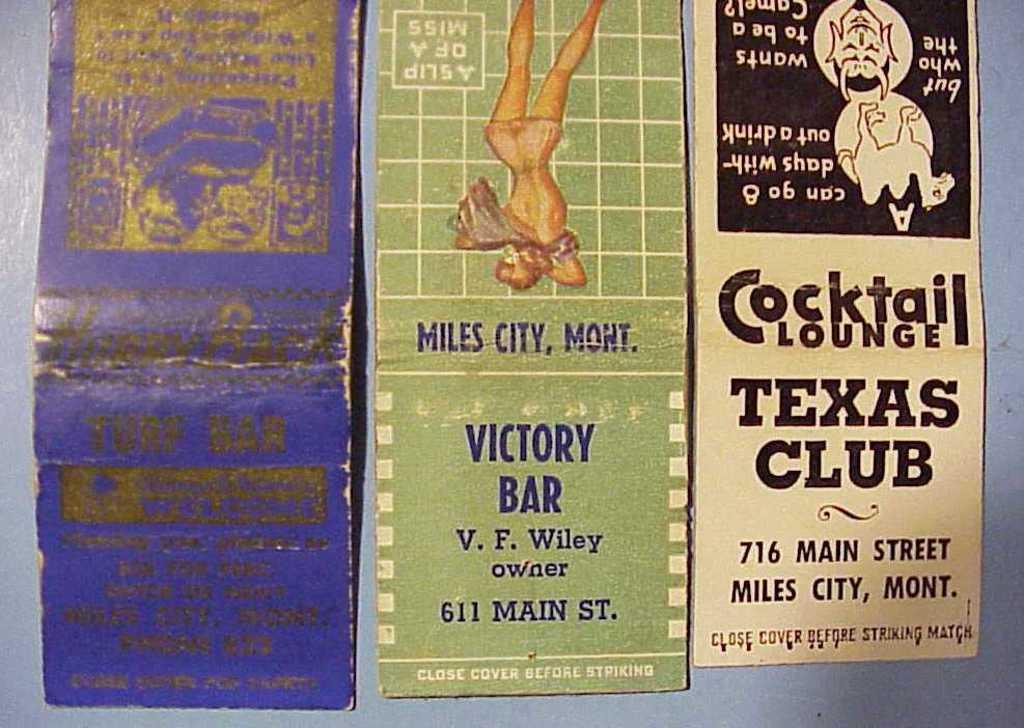What type of lounge is on main street?
Offer a very short reply. Cocktail. 